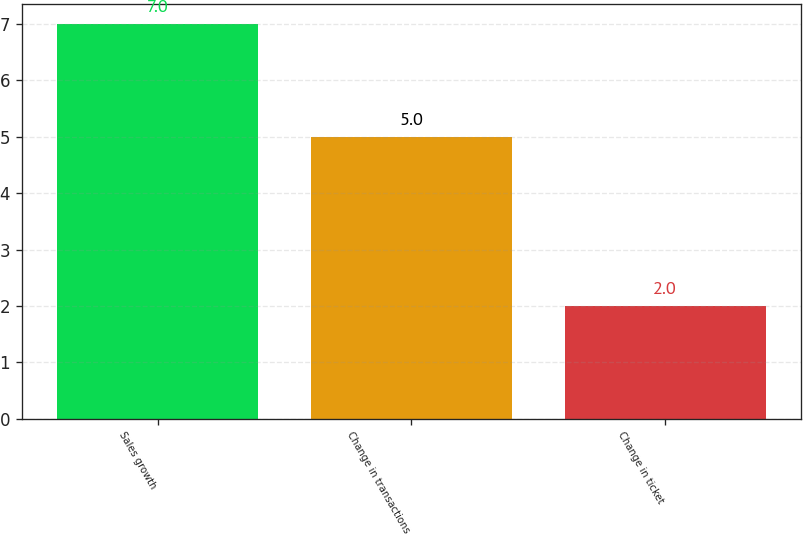<chart> <loc_0><loc_0><loc_500><loc_500><bar_chart><fcel>Sales growth<fcel>Change in transactions<fcel>Change in ticket<nl><fcel>7<fcel>5<fcel>2<nl></chart> 